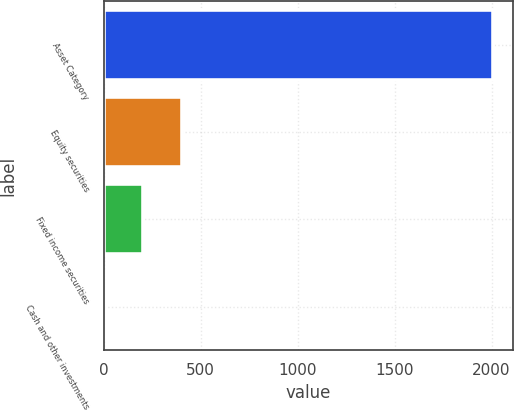Convert chart. <chart><loc_0><loc_0><loc_500><loc_500><bar_chart><fcel>Asset Category<fcel>Equity securities<fcel>Fixed income securities<fcel>Cash and other investments<nl><fcel>2008<fcel>403.2<fcel>202.6<fcel>2<nl></chart> 